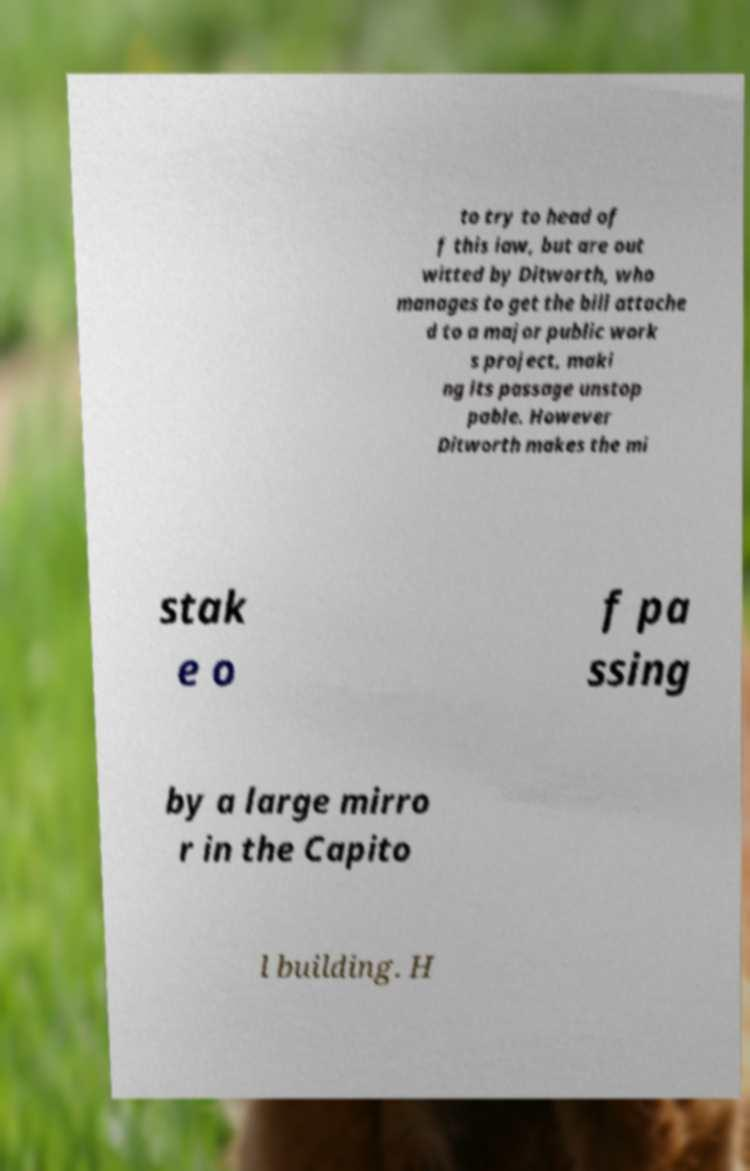What messages or text are displayed in this image? I need them in a readable, typed format. to try to head of f this law, but are out witted by Ditworth, who manages to get the bill attache d to a major public work s project, maki ng its passage unstop pable. However Ditworth makes the mi stak e o f pa ssing by a large mirro r in the Capito l building. H 